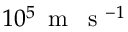Convert formula to latex. <formula><loc_0><loc_0><loc_500><loc_500>1 0 ^ { 5 } \, m \, s ^ { - 1 }</formula> 